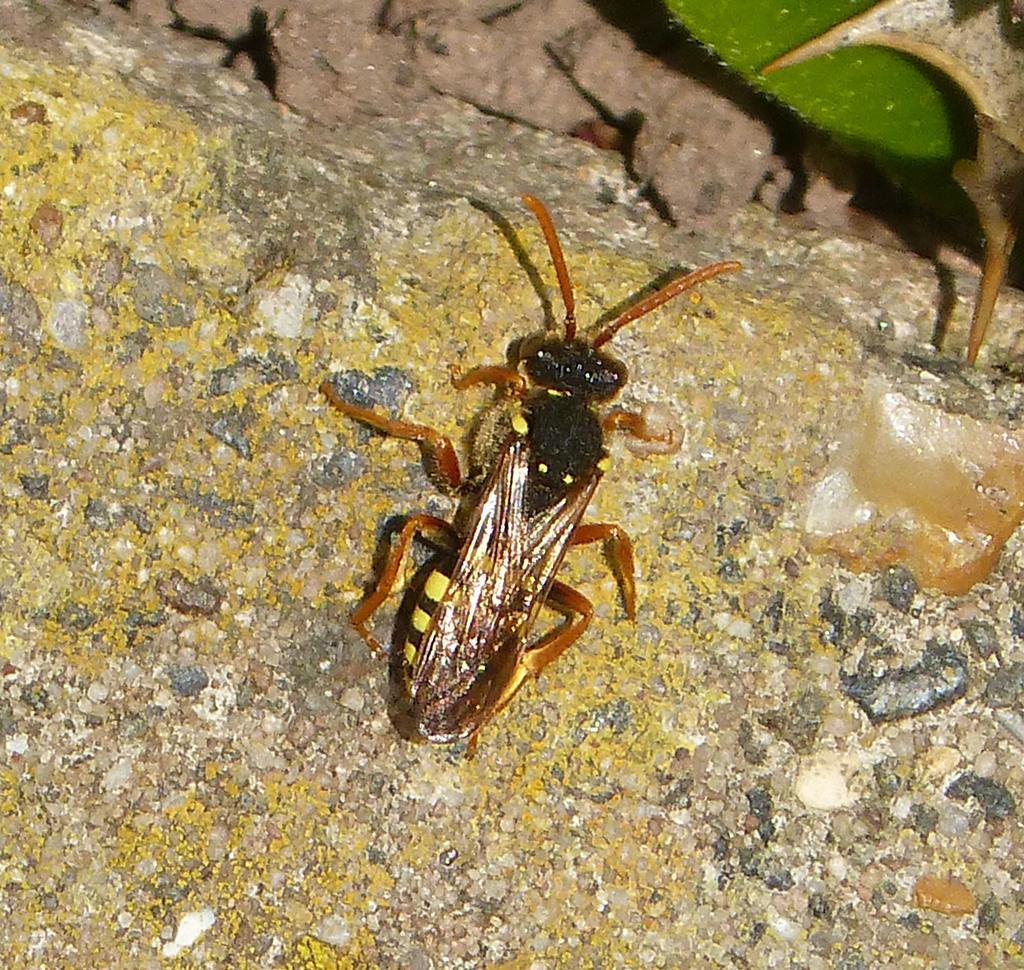How would you summarize this image in a sentence or two? In this picture we can see an insect here, at the right top of the image we can see a leaf. 